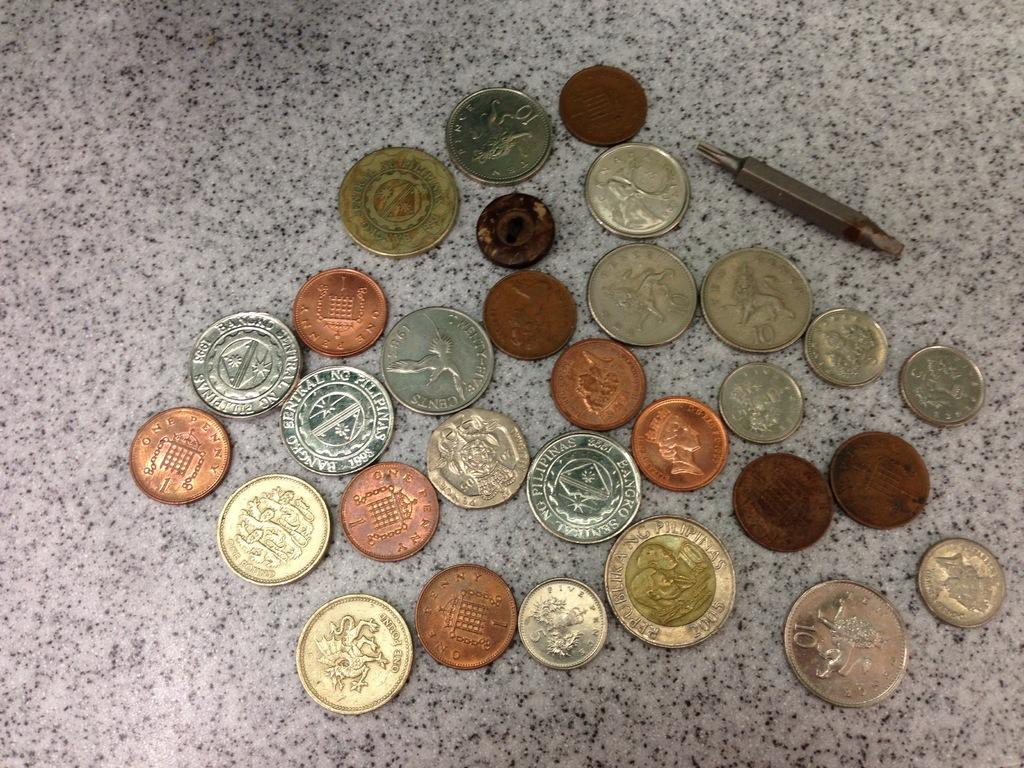<image>
Render a clear and concise summary of the photo. A random collection of coins include some from the Philippines. 